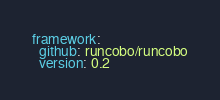Convert code to text. <code><loc_0><loc_0><loc_500><loc_500><_YAML_>framework:
  github: runcobo/runcobo
  version: 0.2
</code> 